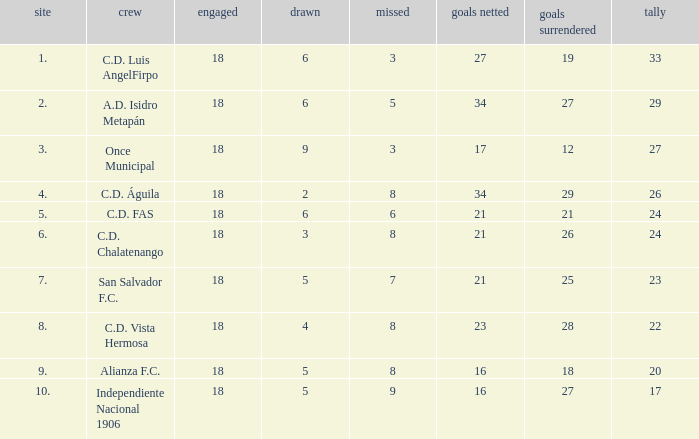For Once Municipal, what were the goals scored that had less than 27 points and greater than place 1? None. 